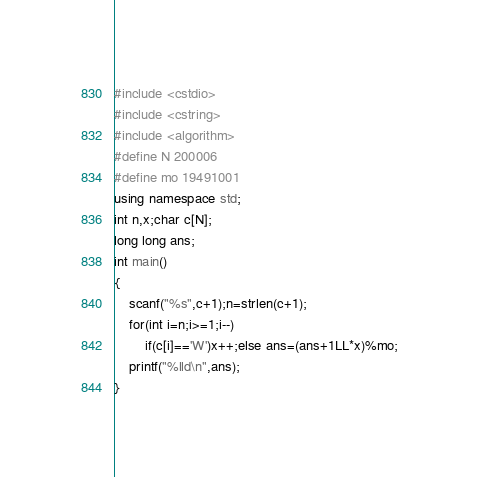<code> <loc_0><loc_0><loc_500><loc_500><_C++_>#include <cstdio>
#include <cstring>
#include <algorithm>
#define N 200006
#define mo 19491001
using namespace std;
int n,x;char c[N];
long long ans;
int main()
{
	scanf("%s",c+1);n=strlen(c+1);
	for(int i=n;i>=1;i--)
		if(c[i]=='W')x++;else ans=(ans+1LL*x)%mo;
	printf("%lld\n",ans);
}</code> 